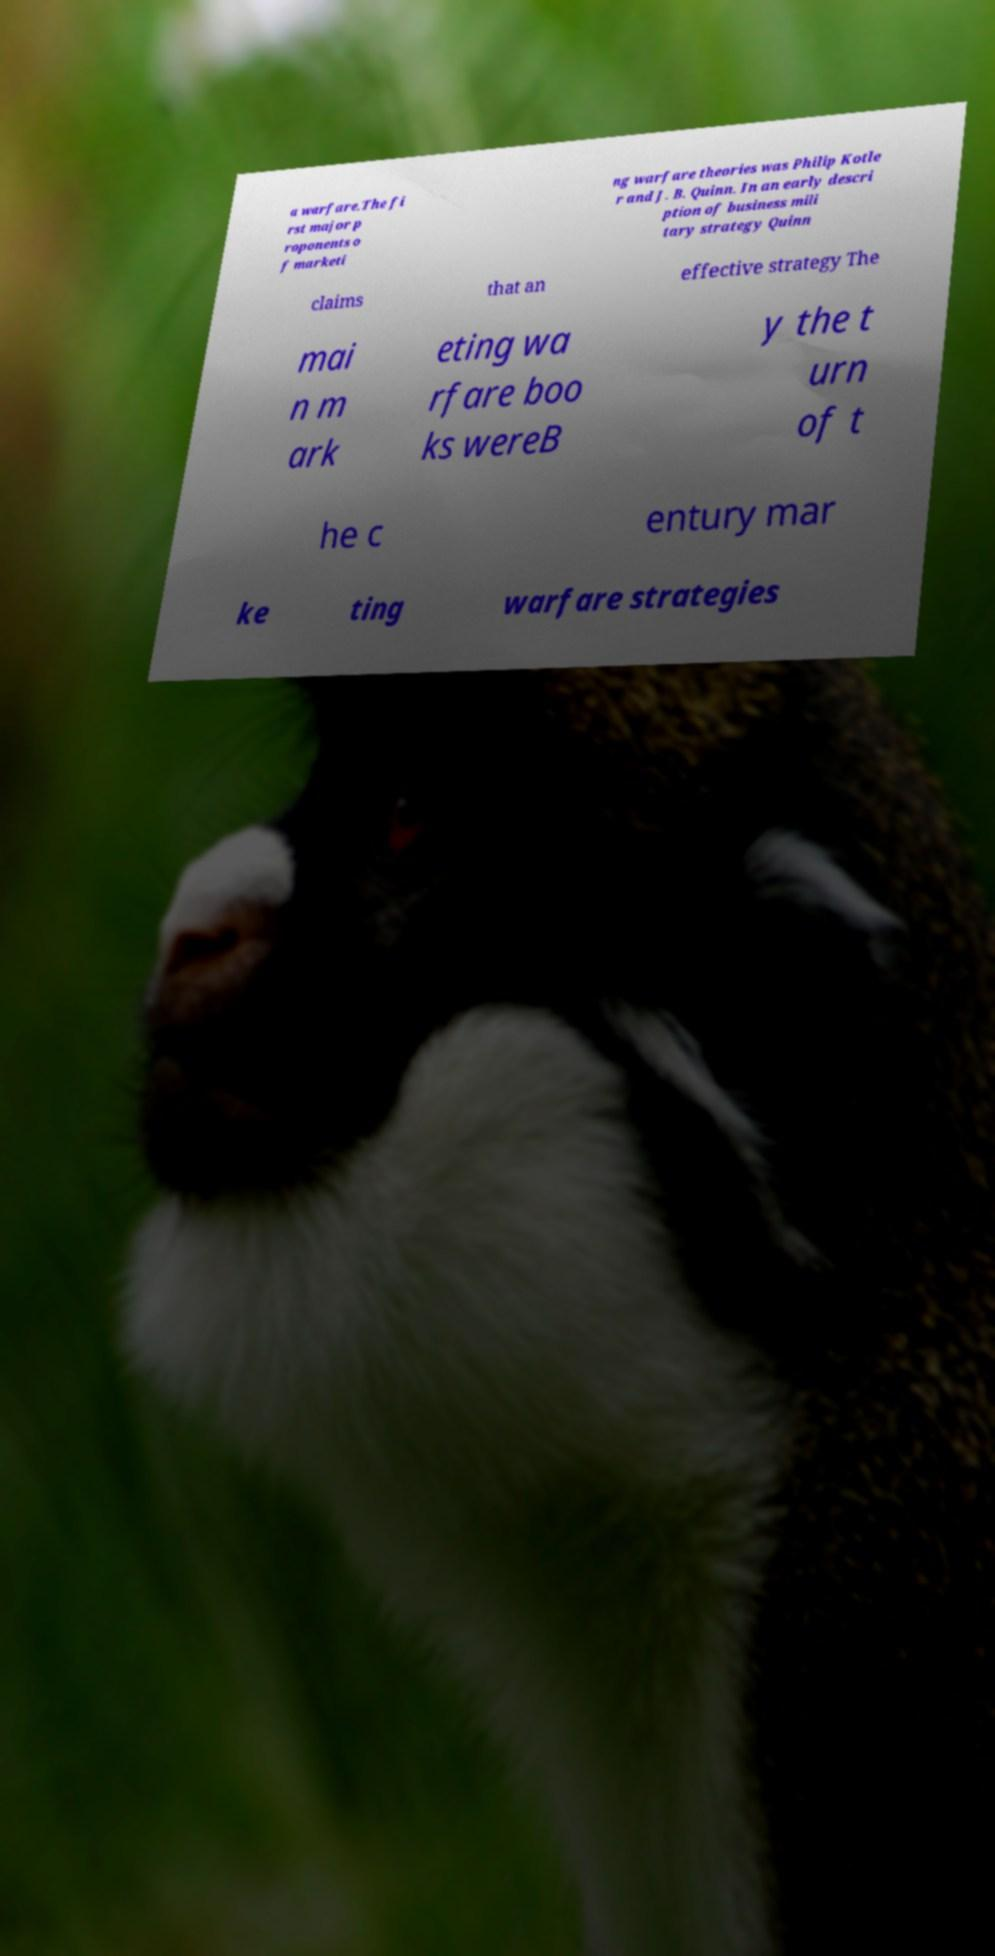Can you accurately transcribe the text from the provided image for me? a warfare.The fi rst major p roponents o f marketi ng warfare theories was Philip Kotle r and J. B. Quinn. In an early descri ption of business mili tary strategy Quinn claims that an effective strategy The mai n m ark eting wa rfare boo ks wereB y the t urn of t he c entury mar ke ting warfare strategies 